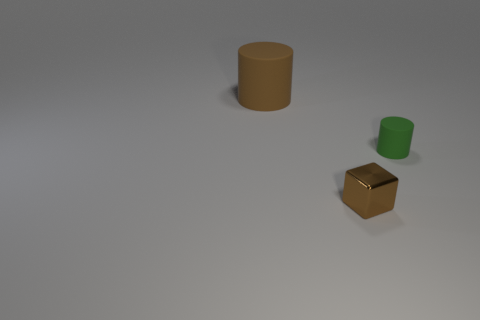Add 3 tiny cyan spheres. How many objects exist? 6 Subtract all cylinders. How many objects are left? 1 Subtract 0 purple cylinders. How many objects are left? 3 Subtract all matte objects. Subtract all tiny cylinders. How many objects are left? 0 Add 2 small shiny things. How many small shiny things are left? 3 Add 1 large green objects. How many large green objects exist? 1 